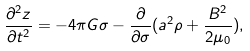Convert formula to latex. <formula><loc_0><loc_0><loc_500><loc_500>\frac { \partial ^ { 2 } z } { \partial t ^ { 2 } } = - 4 \pi G \sigma - \frac { \partial } { \partial \sigma } ( a ^ { 2 } \rho + \frac { B ^ { 2 } } { 2 \mu _ { 0 } } ) ,</formula> 